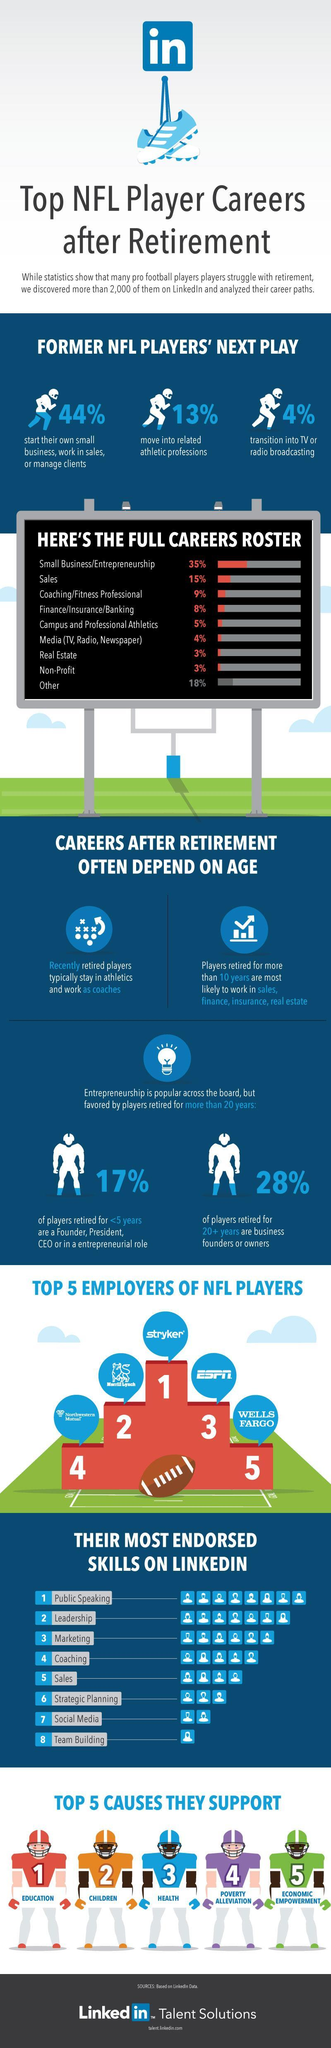What percentage of former NFL players move into related athletic professions?
Answer the question with a short phrase. 13% What is the most endorsed skill of former NFL players on LinkedIn? Public Speaking What percentage of former NFL players moved into real estate professions? 3% Who is the top employer on LinkedIn for former NFL players? Stryker What percentage of NFL players retired for 20+ years are business founders or owners? 28% 